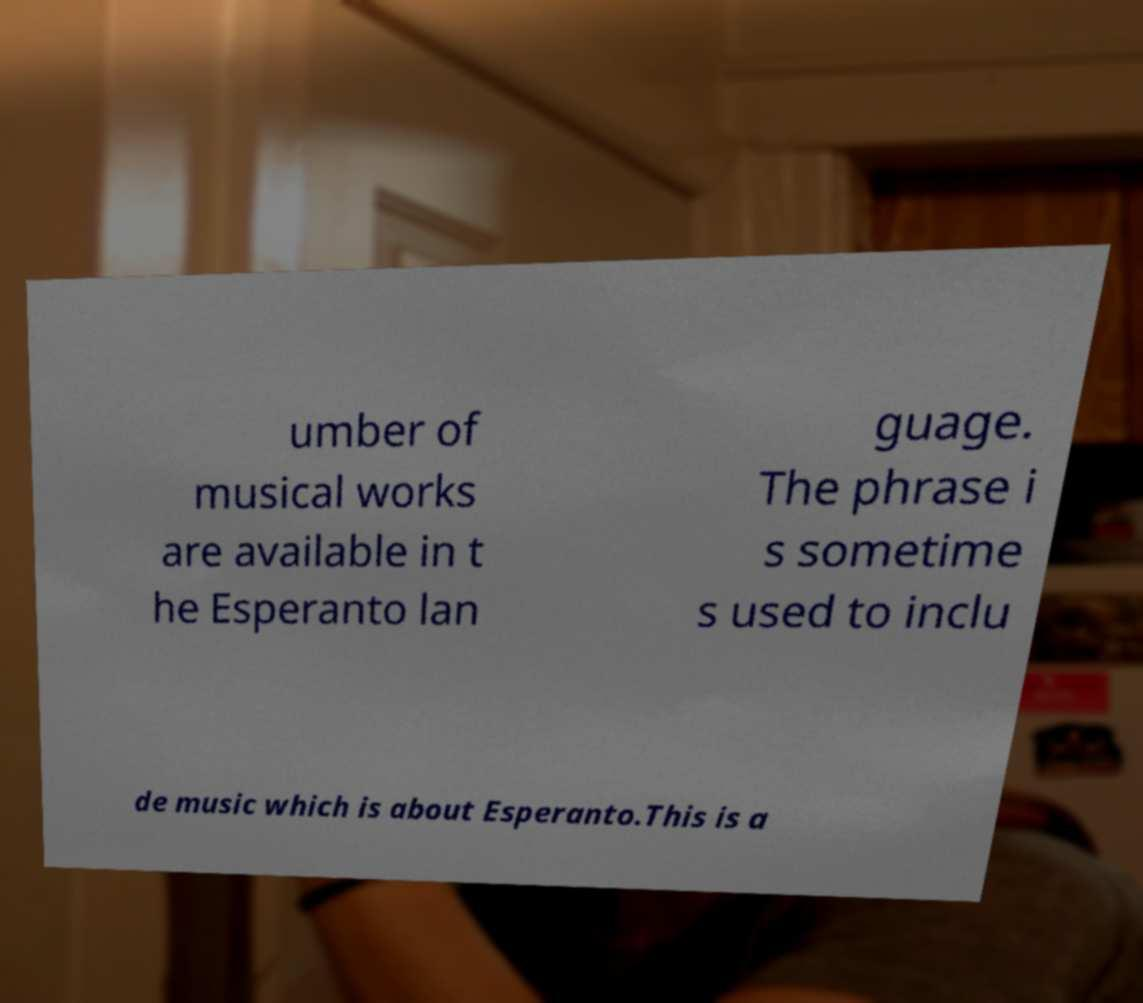Please identify and transcribe the text found in this image. umber of musical works are available in t he Esperanto lan guage. The phrase i s sometime s used to inclu de music which is about Esperanto.This is a 